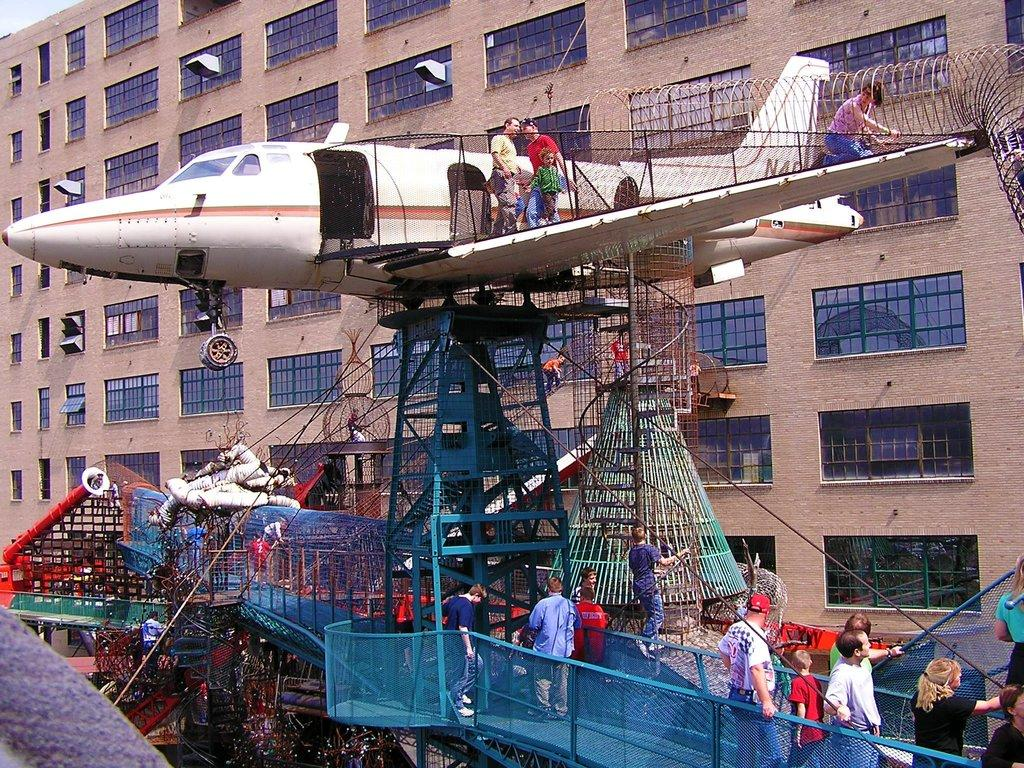What type of structure is visible in the image? There is a building in the image. What else can be seen in the image besides the building? There is an aircraft model and a group of people standing in the image. What type of glass can be seen in the image? There is no glass present in the image. Can you see the sea in the background of the image? The image does not show the sea or any body of water in the background. 